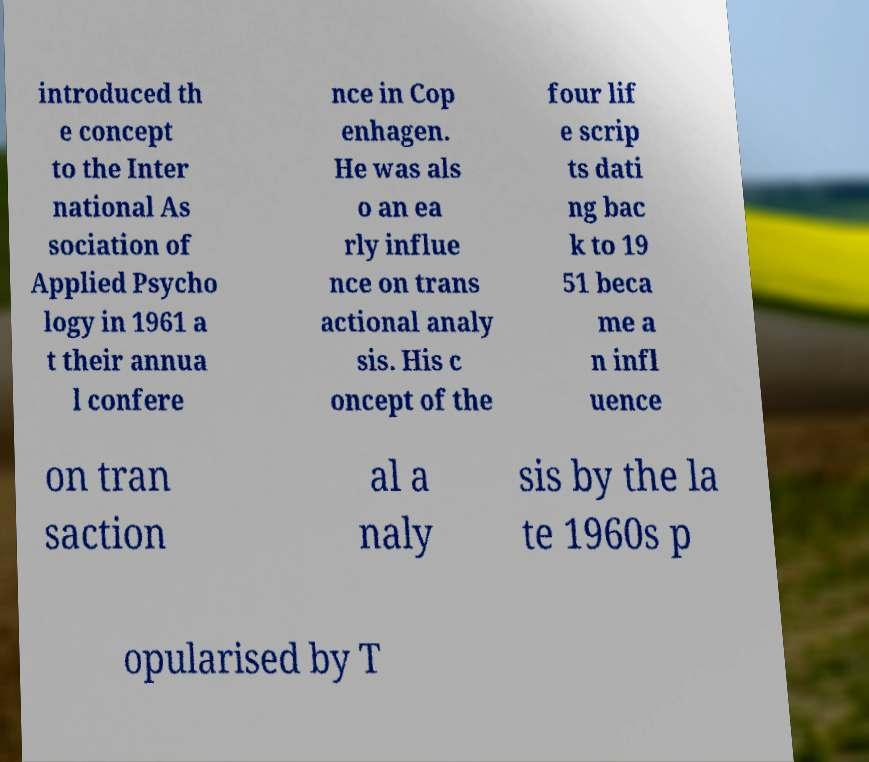I need the written content from this picture converted into text. Can you do that? introduced th e concept to the Inter national As sociation of Applied Psycho logy in 1961 a t their annua l confere nce in Cop enhagen. He was als o an ea rly influe nce on trans actional analy sis. His c oncept of the four lif e scrip ts dati ng bac k to 19 51 beca me a n infl uence on tran saction al a naly sis by the la te 1960s p opularised by T 